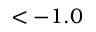Convert formula to latex. <formula><loc_0><loc_0><loc_500><loc_500>< - 1 . 0</formula> 